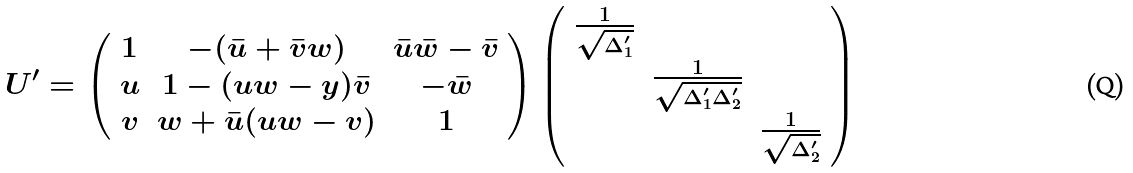Convert formula to latex. <formula><loc_0><loc_0><loc_500><loc_500>U ^ { \prime } = \left ( \begin{array} { c c c } 1 & - ( \bar { u } + \bar { v } w ) & \bar { u } \bar { w } - \bar { v } \\ u & 1 - ( u w - y ) \bar { v } & - \bar { w } \\ v & w + \bar { u } ( u w - v ) & 1 \end{array} \right ) \left ( \begin{array} { c c c } \frac { 1 } { \sqrt { \Delta _ { 1 } ^ { \prime } } } & & \\ & \frac { 1 } { \sqrt { \Delta _ { 1 } ^ { \prime } \Delta _ { 2 } ^ { \prime } } } & \\ & & \frac { 1 } { \sqrt { \Delta _ { 2 } ^ { \prime } } } \end{array} \right )</formula> 